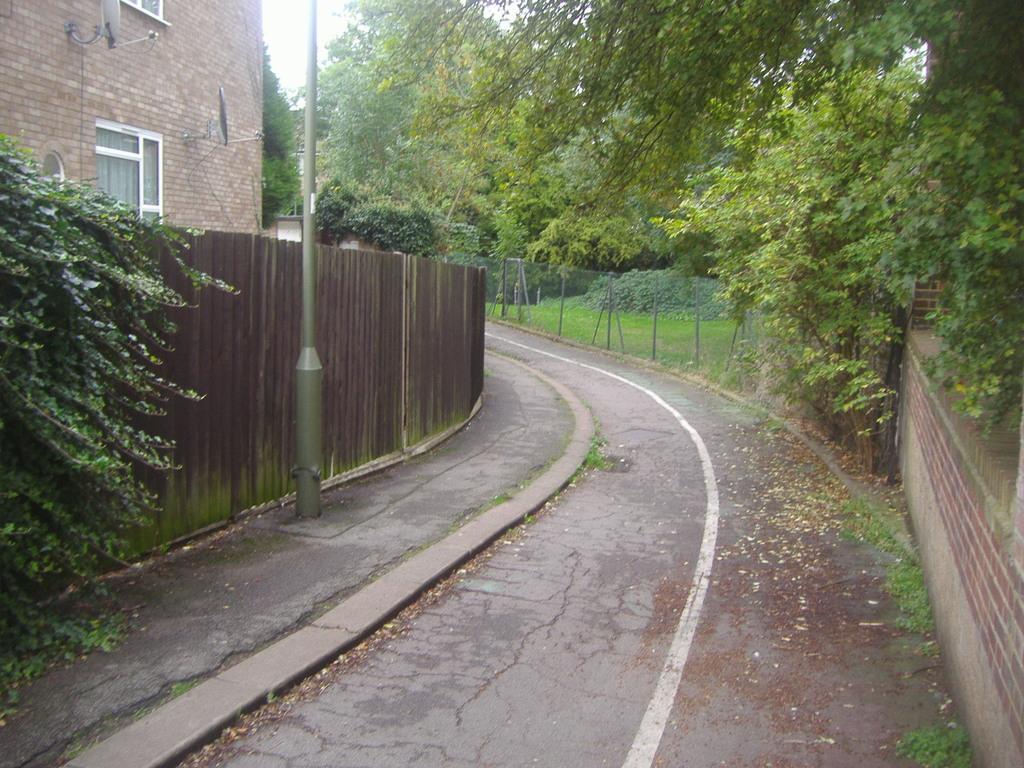How would you summarize this image in a sentence or two? In this image I can see the road. To the right I can see the wall. To the left I can see the pole and wooden fence. On both sides I can see the trees. In the background I can see the railing, many trees, building and the sky. 